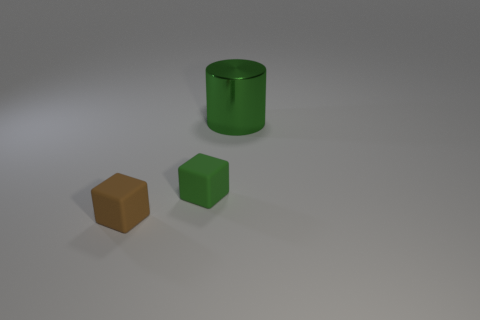Are there fewer green shiny balls than brown rubber cubes?
Give a very brief answer. Yes. Is there a small object behind the rubber block that is in front of the green thing that is in front of the big shiny object?
Your response must be concise. Yes. What number of rubber things are large objects or tiny red objects?
Keep it short and to the point. 0. How many shiny things are behind the metallic object?
Make the answer very short. 0. How many things are behind the brown thing and left of the metal cylinder?
Provide a succinct answer. 1. The tiny brown object that is made of the same material as the green block is what shape?
Keep it short and to the point. Cube. Is the size of the rubber object right of the brown matte block the same as the green thing that is behind the green matte thing?
Keep it short and to the point. No. There is a object that is on the right side of the small green block; what is its color?
Offer a terse response. Green. What is the thing behind the green object in front of the big object made of?
Offer a very short reply. Metal. What is the shape of the small brown thing?
Make the answer very short. Cube. 